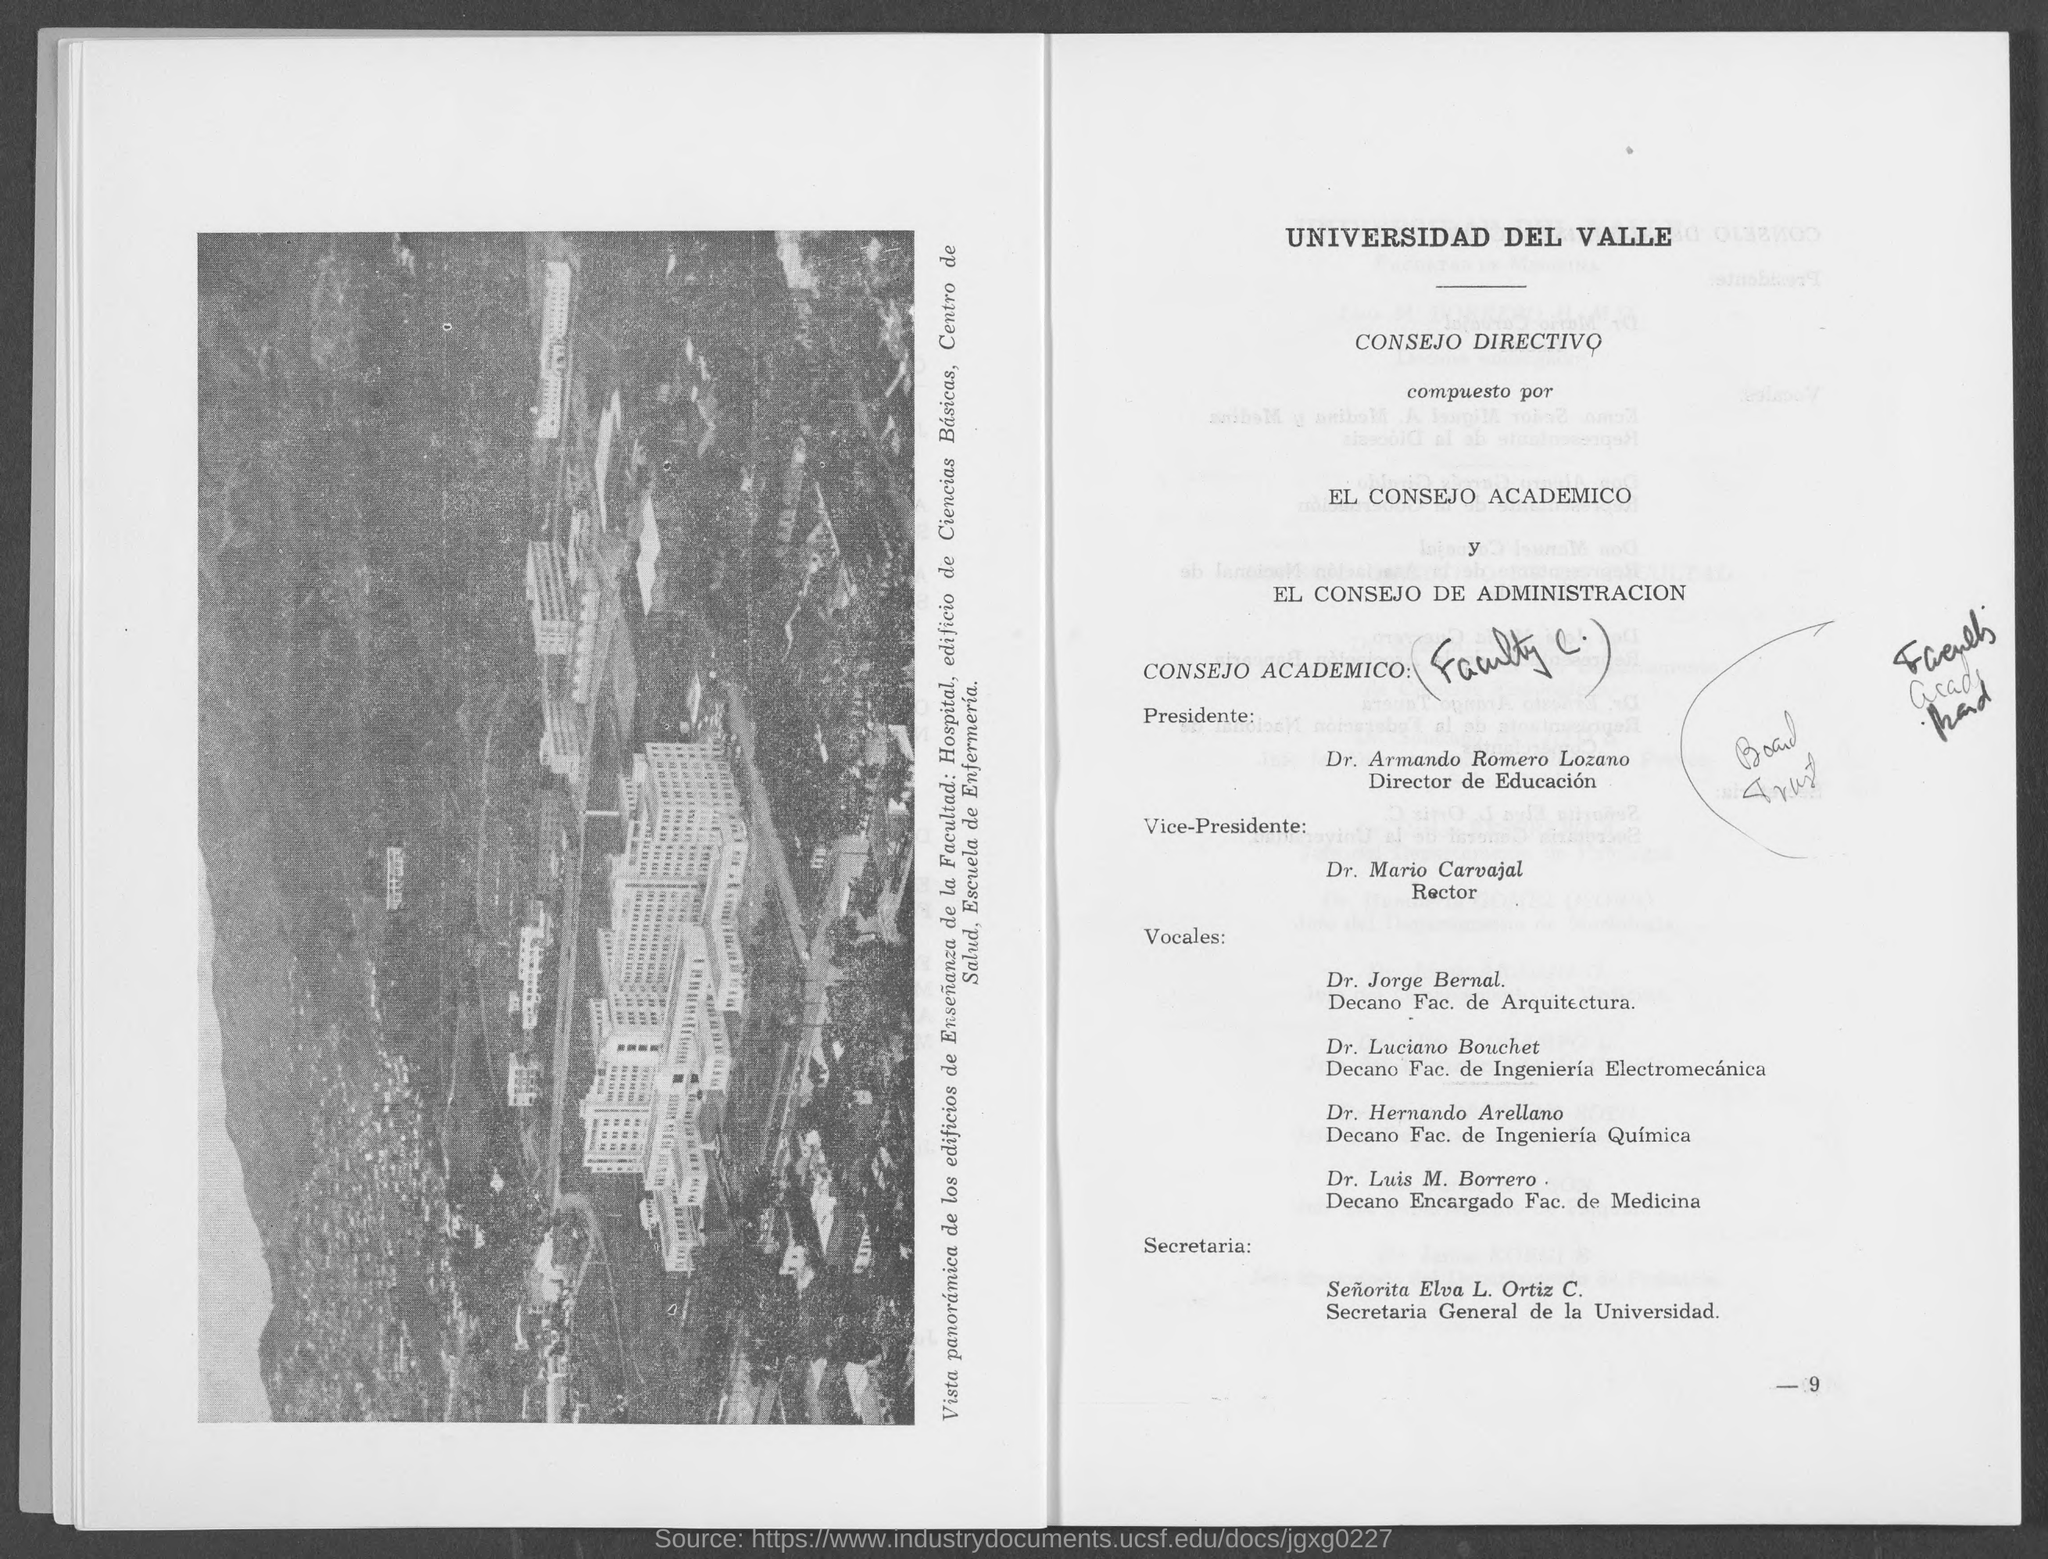Point out several critical features in this image. Please refer to the bottom right corner of the page for the page number provided. 